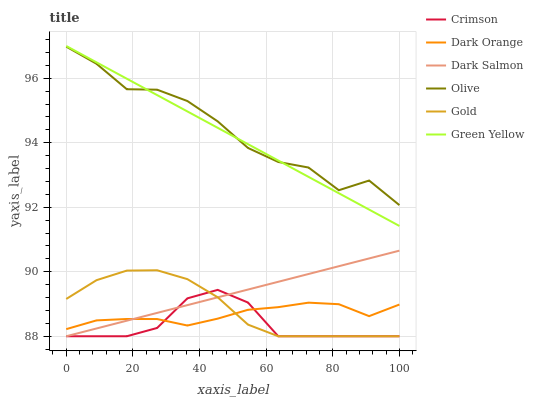Does Crimson have the minimum area under the curve?
Answer yes or no. Yes. Does Olive have the maximum area under the curve?
Answer yes or no. Yes. Does Gold have the minimum area under the curve?
Answer yes or no. No. Does Gold have the maximum area under the curve?
Answer yes or no. No. Is Dark Salmon the smoothest?
Answer yes or no. Yes. Is Olive the roughest?
Answer yes or no. Yes. Is Gold the smoothest?
Answer yes or no. No. Is Gold the roughest?
Answer yes or no. No. Does Olive have the lowest value?
Answer yes or no. No. Does Gold have the highest value?
Answer yes or no. No. Is Crimson less than Olive?
Answer yes or no. Yes. Is Olive greater than Gold?
Answer yes or no. Yes. Does Crimson intersect Olive?
Answer yes or no. No. 